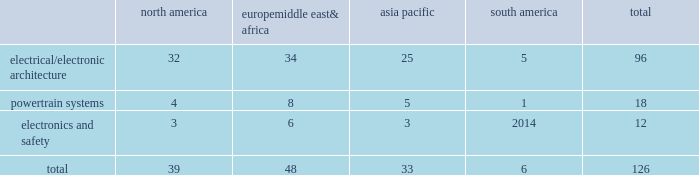Taxing authorities could challenge our historical and future tax positions .
Our future effective tax rates could be affected by changes in the mix of earnings in countries with differing statutory rates and changes in tax laws or their interpretation including changes related to tax holidays or tax incentives .
Our taxes could increase if certain tax holidays or incentives are not renewed upon expiration , or if tax rates or regimes applicable to us in such jurisdictions are otherwise increased .
The amount of tax we pay is subject to our interpretation of applicable tax laws in the jurisdictions in which we file .
We have taken and will continue to take tax positions based on our interpretation of such tax laws .
In particular , we will seek to organize and operate ourselves in such a way that we are and remain tax resident in the united kingdom .
Additionally , in determining the adequacy of our provision for income taxes , we regularly assess the likelihood of adverse outcomes resulting from tax examinations .
While it is often difficult to predict the final outcome or the timing of the resolution of a tax examination , our reserves for uncertain tax benefits reflect the outcome of tax positions that are more likely than not to occur .
While we believe that we have complied with all applicable tax laws , there can be no assurance that a taxing authority will not have a different interpretation of the law and assess us with additional taxes .
Should additional taxes be assessed , this may result in a material adverse effect on our results of operations and financial condition .
Item 1b .
Unresolved staff comments we have no unresolved sec staff comments to report .
Item 2 .
Properties as of december 31 , 2016 , we owned or leased 126 major manufacturing sites and 15 major technical centers .
A manufacturing site may include multiple plants and may be wholly or partially owned or leased .
We also have many smaller manufacturing sites , sales offices , warehouses , engineering centers , joint ventures and other investments strategically located throughout the world .
We have a presence in 46 countries .
The table shows the regional distribution of our major manufacturing sites by the operating segment that uses such facilities : north america europe , middle east & africa asia pacific south america total .
In addition to these manufacturing sites , we had 15 major technical centers : five in north america ; five in europe , middle east and africa ; four in asia pacific ; and one in south america .
Of our 126 major manufacturing sites and 15 major technical centers , which include facilities owned or leased by our consolidated subsidiaries , 75 are primarily owned and 66 are primarily leased .
We frequently review our real estate portfolio and develop footprint strategies to support our customers 2019 global plans , while at the same time supporting our technical needs and controlling operating expenses .
We believe our evolving portfolio will meet current and anticipated future needs .
Item 3 .
Legal proceedings we are from time to time subject to various actions , claims , suits , government investigations , and other proceedings incidental to our business , including those arising out of alleged defects , breach of contracts , competition and antitrust matters , product warranties , intellectual property matters , personal injury claims and employment-related matters .
It is our opinion that the outcome of such matters will not have a material adverse impact on our consolidated financial position , results of operations , or cash flows .
With respect to warranty matters , although we cannot ensure that the future costs of warranty claims by customers will not be material , we believe our established reserves are adequate to cover potential warranty settlements .
However , the final amounts required to resolve these matters could differ materially from our recorded estimates. .
What is the percentage of electronics and safety sites among all sites? 
Rationale: it is the number of sites related to electronics and safety divided by the total sites .
Computations: (12 / 126)
Answer: 0.09524. 